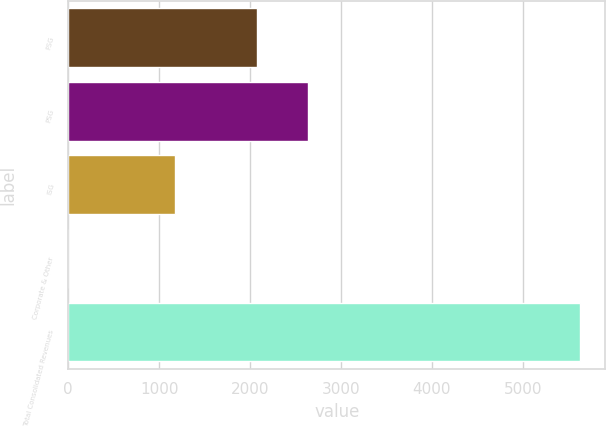<chart> <loc_0><loc_0><loc_500><loc_500><bar_chart><fcel>FSG<fcel>PSG<fcel>ISG<fcel>Corporate & Other<fcel>Total Consolidated Revenues<nl><fcel>2076.8<fcel>2639.27<fcel>1177.6<fcel>0.9<fcel>5625.6<nl></chart> 